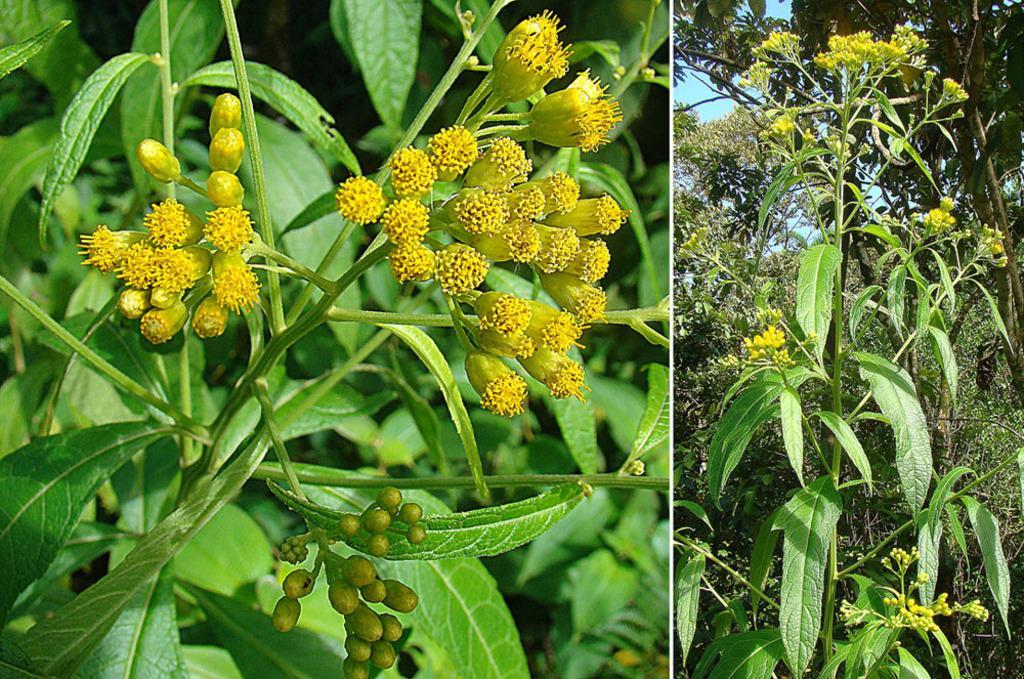In one or two sentences, can you explain what this image depicts? In this picture, we can see a collage image, we can see trees, plants, buds, and the sky. 